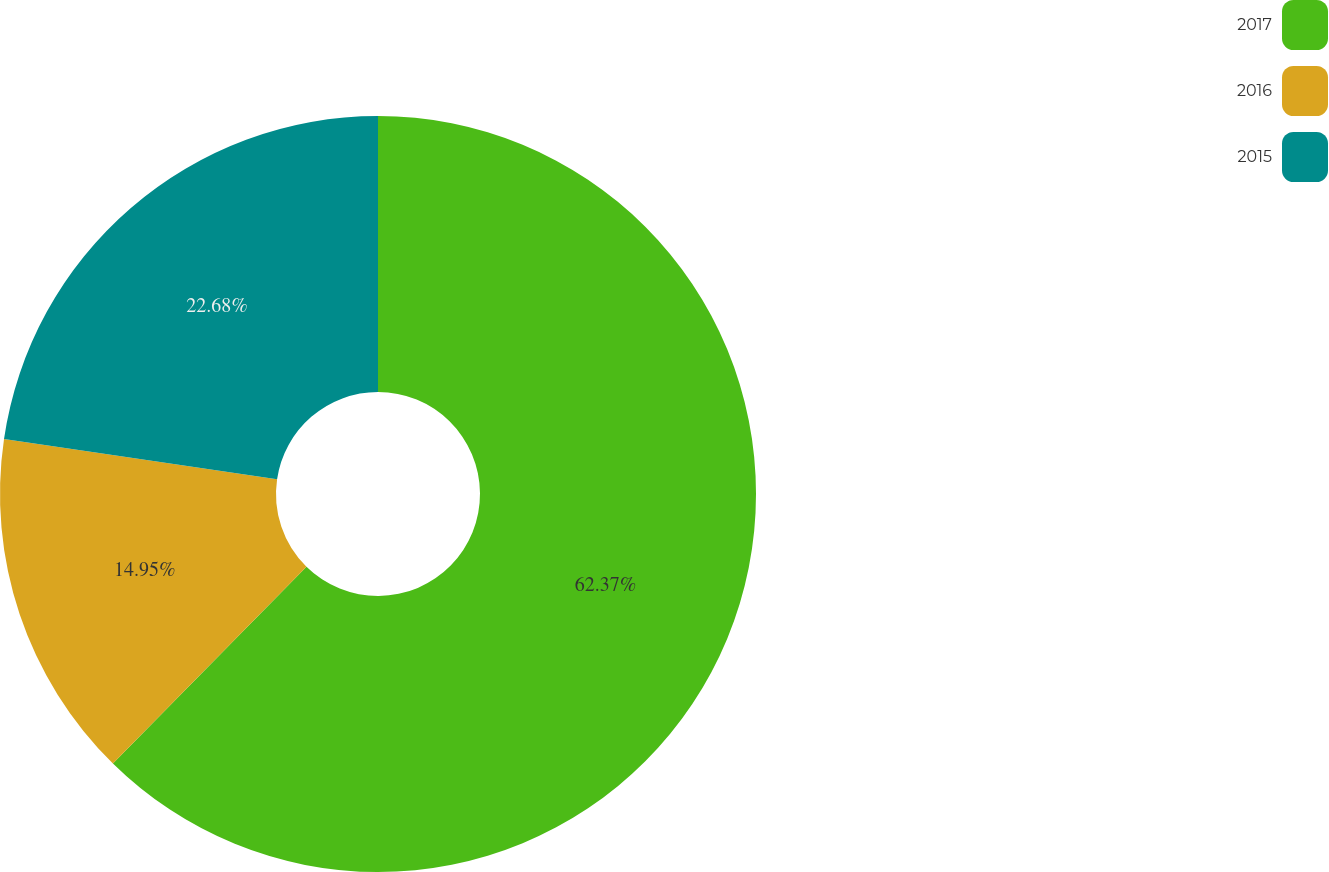Convert chart. <chart><loc_0><loc_0><loc_500><loc_500><pie_chart><fcel>2017<fcel>2016<fcel>2015<nl><fcel>62.37%<fcel>14.95%<fcel>22.68%<nl></chart> 